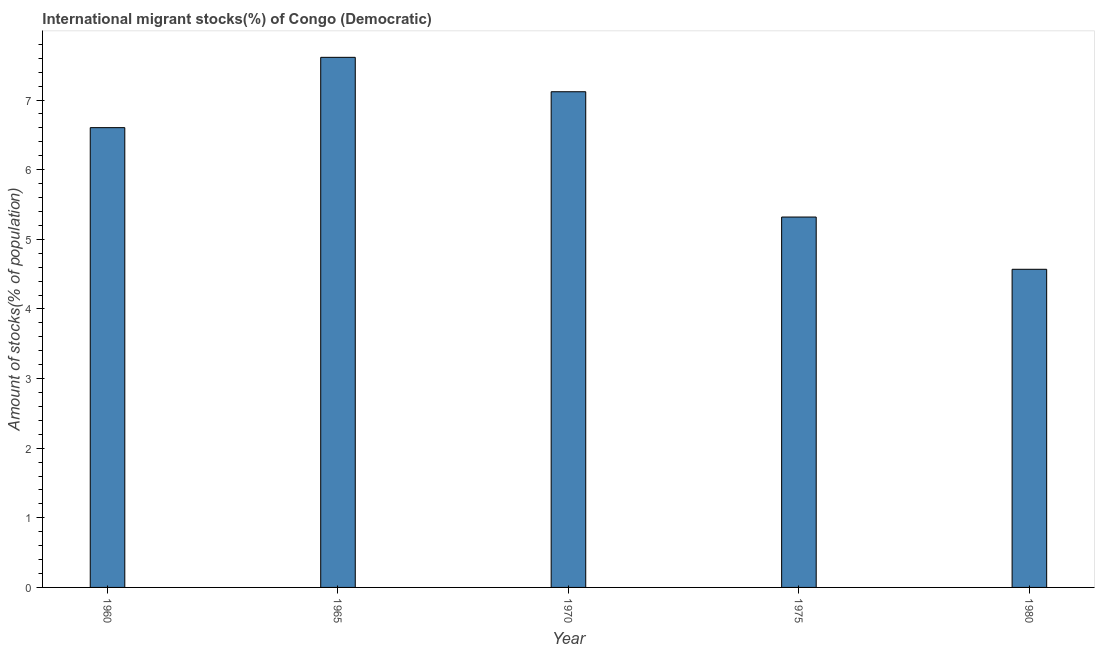Does the graph contain any zero values?
Make the answer very short. No. What is the title of the graph?
Ensure brevity in your answer.  International migrant stocks(%) of Congo (Democratic). What is the label or title of the X-axis?
Offer a very short reply. Year. What is the label or title of the Y-axis?
Make the answer very short. Amount of stocks(% of population). What is the number of international migrant stocks in 1965?
Ensure brevity in your answer.  7.61. Across all years, what is the maximum number of international migrant stocks?
Keep it short and to the point. 7.61. Across all years, what is the minimum number of international migrant stocks?
Your answer should be very brief. 4.57. In which year was the number of international migrant stocks maximum?
Your response must be concise. 1965. What is the sum of the number of international migrant stocks?
Keep it short and to the point. 31.23. What is the difference between the number of international migrant stocks in 1960 and 1965?
Provide a short and direct response. -1.01. What is the average number of international migrant stocks per year?
Give a very brief answer. 6.25. What is the median number of international migrant stocks?
Provide a short and direct response. 6.6. In how many years, is the number of international migrant stocks greater than 5.4 %?
Provide a short and direct response. 3. What is the ratio of the number of international migrant stocks in 1975 to that in 1980?
Make the answer very short. 1.16. Is the number of international migrant stocks in 1960 less than that in 1980?
Make the answer very short. No. Is the difference between the number of international migrant stocks in 1965 and 1980 greater than the difference between any two years?
Give a very brief answer. Yes. What is the difference between the highest and the second highest number of international migrant stocks?
Ensure brevity in your answer.  0.49. What is the difference between the highest and the lowest number of international migrant stocks?
Offer a terse response. 3.04. What is the Amount of stocks(% of population) of 1960?
Provide a short and direct response. 6.6. What is the Amount of stocks(% of population) in 1965?
Offer a terse response. 7.61. What is the Amount of stocks(% of population) of 1970?
Keep it short and to the point. 7.12. What is the Amount of stocks(% of population) of 1975?
Provide a succinct answer. 5.32. What is the Amount of stocks(% of population) of 1980?
Keep it short and to the point. 4.57. What is the difference between the Amount of stocks(% of population) in 1960 and 1965?
Give a very brief answer. -1.01. What is the difference between the Amount of stocks(% of population) in 1960 and 1970?
Ensure brevity in your answer.  -0.52. What is the difference between the Amount of stocks(% of population) in 1960 and 1975?
Your answer should be compact. 1.28. What is the difference between the Amount of stocks(% of population) in 1960 and 1980?
Ensure brevity in your answer.  2.03. What is the difference between the Amount of stocks(% of population) in 1965 and 1970?
Provide a short and direct response. 0.49. What is the difference between the Amount of stocks(% of population) in 1965 and 1975?
Your response must be concise. 2.29. What is the difference between the Amount of stocks(% of population) in 1965 and 1980?
Give a very brief answer. 3.04. What is the difference between the Amount of stocks(% of population) in 1970 and 1975?
Give a very brief answer. 1.8. What is the difference between the Amount of stocks(% of population) in 1970 and 1980?
Give a very brief answer. 2.55. What is the difference between the Amount of stocks(% of population) in 1975 and 1980?
Offer a terse response. 0.75. What is the ratio of the Amount of stocks(% of population) in 1960 to that in 1965?
Provide a succinct answer. 0.87. What is the ratio of the Amount of stocks(% of population) in 1960 to that in 1970?
Your answer should be compact. 0.93. What is the ratio of the Amount of stocks(% of population) in 1960 to that in 1975?
Your answer should be very brief. 1.24. What is the ratio of the Amount of stocks(% of population) in 1960 to that in 1980?
Keep it short and to the point. 1.45. What is the ratio of the Amount of stocks(% of population) in 1965 to that in 1970?
Provide a short and direct response. 1.07. What is the ratio of the Amount of stocks(% of population) in 1965 to that in 1975?
Ensure brevity in your answer.  1.43. What is the ratio of the Amount of stocks(% of population) in 1965 to that in 1980?
Provide a succinct answer. 1.67. What is the ratio of the Amount of stocks(% of population) in 1970 to that in 1975?
Offer a very short reply. 1.34. What is the ratio of the Amount of stocks(% of population) in 1970 to that in 1980?
Make the answer very short. 1.56. What is the ratio of the Amount of stocks(% of population) in 1975 to that in 1980?
Your answer should be compact. 1.16. 